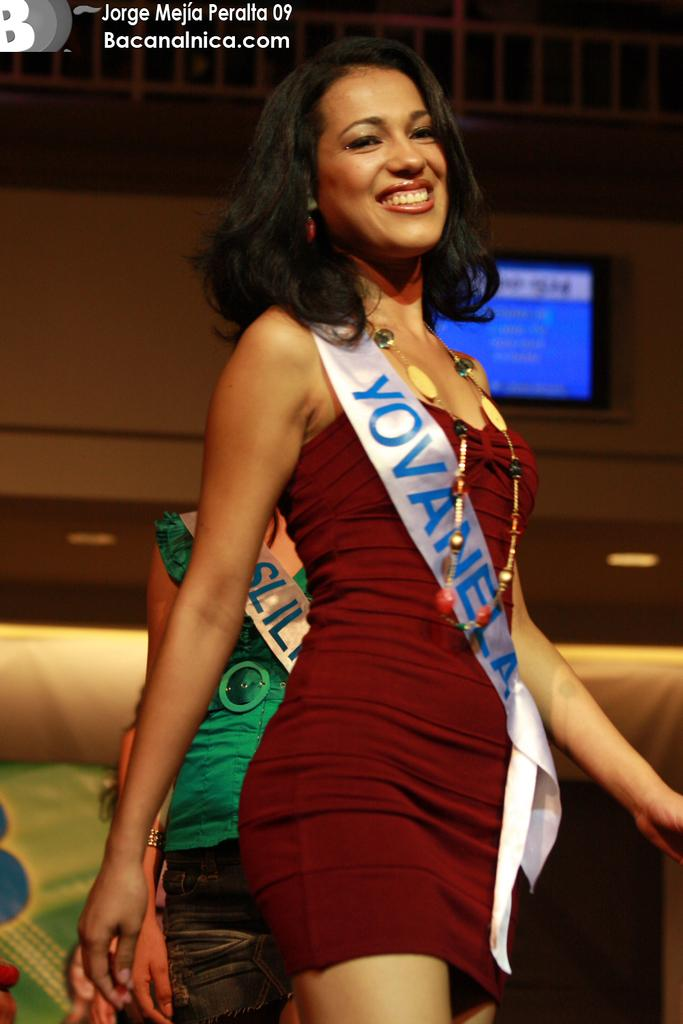<image>
Describe the image concisely. A contestant in a short, dark red dress, wears a sash saying, "YOVANELA". 